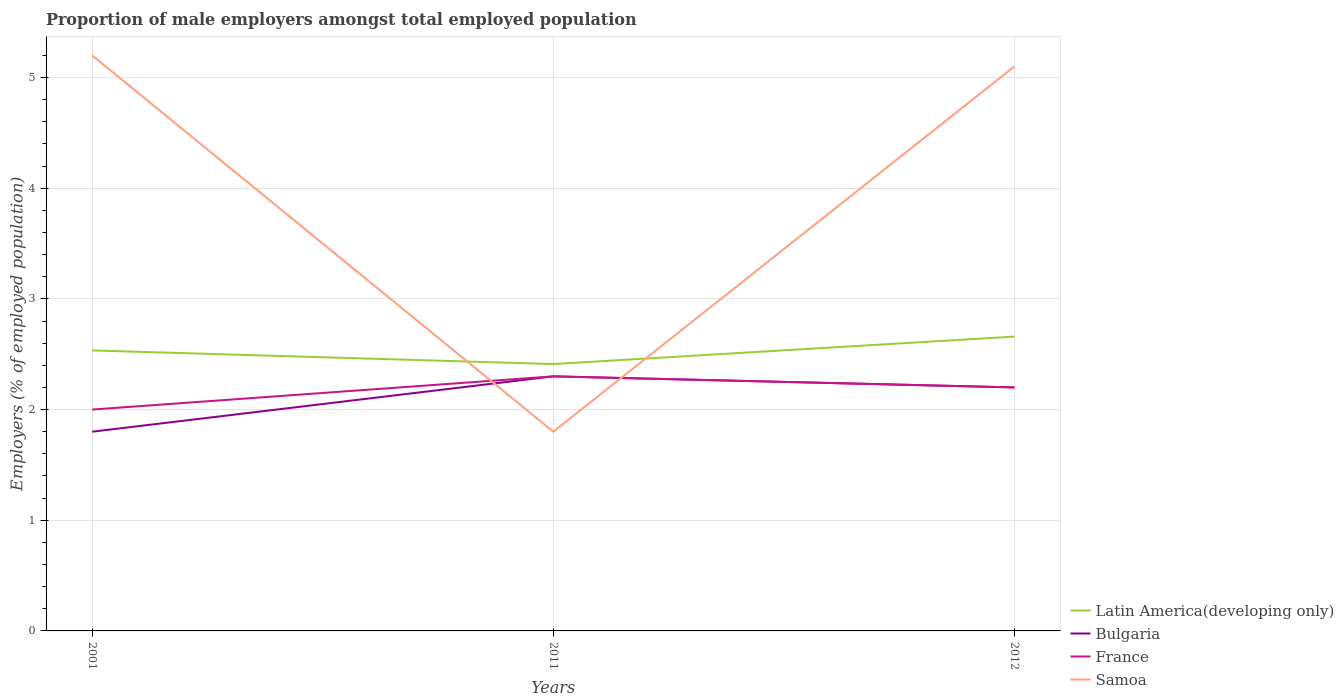Does the line corresponding to Samoa intersect with the line corresponding to Bulgaria?
Give a very brief answer. Yes. Across all years, what is the maximum proportion of male employers in Bulgaria?
Offer a very short reply. 1.8. What is the total proportion of male employers in Samoa in the graph?
Offer a very short reply. 0.1. What is the difference between the highest and the second highest proportion of male employers in France?
Your answer should be compact. 0.3. What is the difference between the highest and the lowest proportion of male employers in Samoa?
Your answer should be very brief. 2. Is the proportion of male employers in Latin America(developing only) strictly greater than the proportion of male employers in France over the years?
Your answer should be very brief. No. Does the graph contain any zero values?
Give a very brief answer. No. Does the graph contain grids?
Offer a very short reply. Yes. Where does the legend appear in the graph?
Ensure brevity in your answer.  Bottom right. What is the title of the graph?
Provide a succinct answer. Proportion of male employers amongst total employed population. What is the label or title of the Y-axis?
Offer a terse response. Employers (% of employed population). What is the Employers (% of employed population) of Latin America(developing only) in 2001?
Give a very brief answer. 2.53. What is the Employers (% of employed population) of Bulgaria in 2001?
Your answer should be compact. 1.8. What is the Employers (% of employed population) of Samoa in 2001?
Your response must be concise. 5.2. What is the Employers (% of employed population) in Latin America(developing only) in 2011?
Your answer should be very brief. 2.41. What is the Employers (% of employed population) of Bulgaria in 2011?
Offer a very short reply. 2.3. What is the Employers (% of employed population) of France in 2011?
Ensure brevity in your answer.  2.3. What is the Employers (% of employed population) in Samoa in 2011?
Provide a short and direct response. 1.8. What is the Employers (% of employed population) in Latin America(developing only) in 2012?
Ensure brevity in your answer.  2.66. What is the Employers (% of employed population) in Bulgaria in 2012?
Your answer should be very brief. 2.2. What is the Employers (% of employed population) in France in 2012?
Provide a short and direct response. 2.2. What is the Employers (% of employed population) in Samoa in 2012?
Offer a very short reply. 5.1. Across all years, what is the maximum Employers (% of employed population) of Latin America(developing only)?
Provide a short and direct response. 2.66. Across all years, what is the maximum Employers (% of employed population) in Bulgaria?
Provide a short and direct response. 2.3. Across all years, what is the maximum Employers (% of employed population) of France?
Provide a succinct answer. 2.3. Across all years, what is the maximum Employers (% of employed population) of Samoa?
Provide a short and direct response. 5.2. Across all years, what is the minimum Employers (% of employed population) of Latin America(developing only)?
Make the answer very short. 2.41. Across all years, what is the minimum Employers (% of employed population) in Bulgaria?
Provide a succinct answer. 1.8. Across all years, what is the minimum Employers (% of employed population) in Samoa?
Your response must be concise. 1.8. What is the total Employers (% of employed population) in Latin America(developing only) in the graph?
Your response must be concise. 7.6. What is the total Employers (% of employed population) of Bulgaria in the graph?
Provide a succinct answer. 6.3. What is the total Employers (% of employed population) in France in the graph?
Your response must be concise. 6.5. What is the total Employers (% of employed population) in Samoa in the graph?
Your response must be concise. 12.1. What is the difference between the Employers (% of employed population) of Latin America(developing only) in 2001 and that in 2011?
Give a very brief answer. 0.12. What is the difference between the Employers (% of employed population) of France in 2001 and that in 2011?
Offer a very short reply. -0.3. What is the difference between the Employers (% of employed population) of Latin America(developing only) in 2001 and that in 2012?
Your answer should be very brief. -0.12. What is the difference between the Employers (% of employed population) of France in 2001 and that in 2012?
Keep it short and to the point. -0.2. What is the difference between the Employers (% of employed population) of Samoa in 2001 and that in 2012?
Provide a short and direct response. 0.1. What is the difference between the Employers (% of employed population) in Latin America(developing only) in 2011 and that in 2012?
Provide a short and direct response. -0.25. What is the difference between the Employers (% of employed population) in Bulgaria in 2011 and that in 2012?
Your answer should be compact. 0.1. What is the difference between the Employers (% of employed population) in France in 2011 and that in 2012?
Provide a short and direct response. 0.1. What is the difference between the Employers (% of employed population) of Samoa in 2011 and that in 2012?
Ensure brevity in your answer.  -3.3. What is the difference between the Employers (% of employed population) in Latin America(developing only) in 2001 and the Employers (% of employed population) in Bulgaria in 2011?
Make the answer very short. 0.23. What is the difference between the Employers (% of employed population) in Latin America(developing only) in 2001 and the Employers (% of employed population) in France in 2011?
Keep it short and to the point. 0.23. What is the difference between the Employers (% of employed population) of Latin America(developing only) in 2001 and the Employers (% of employed population) of Samoa in 2011?
Your answer should be very brief. 0.73. What is the difference between the Employers (% of employed population) in Bulgaria in 2001 and the Employers (% of employed population) in Samoa in 2011?
Ensure brevity in your answer.  0. What is the difference between the Employers (% of employed population) of Latin America(developing only) in 2001 and the Employers (% of employed population) of Bulgaria in 2012?
Ensure brevity in your answer.  0.33. What is the difference between the Employers (% of employed population) of Latin America(developing only) in 2001 and the Employers (% of employed population) of France in 2012?
Provide a short and direct response. 0.33. What is the difference between the Employers (% of employed population) of Latin America(developing only) in 2001 and the Employers (% of employed population) of Samoa in 2012?
Ensure brevity in your answer.  -2.57. What is the difference between the Employers (% of employed population) in Bulgaria in 2001 and the Employers (% of employed population) in Samoa in 2012?
Make the answer very short. -3.3. What is the difference between the Employers (% of employed population) in Latin America(developing only) in 2011 and the Employers (% of employed population) in Bulgaria in 2012?
Your answer should be very brief. 0.21. What is the difference between the Employers (% of employed population) of Latin America(developing only) in 2011 and the Employers (% of employed population) of France in 2012?
Your answer should be compact. 0.21. What is the difference between the Employers (% of employed population) in Latin America(developing only) in 2011 and the Employers (% of employed population) in Samoa in 2012?
Provide a short and direct response. -2.69. What is the difference between the Employers (% of employed population) of Bulgaria in 2011 and the Employers (% of employed population) of France in 2012?
Offer a very short reply. 0.1. What is the average Employers (% of employed population) in Latin America(developing only) per year?
Your response must be concise. 2.53. What is the average Employers (% of employed population) of France per year?
Offer a very short reply. 2.17. What is the average Employers (% of employed population) in Samoa per year?
Make the answer very short. 4.03. In the year 2001, what is the difference between the Employers (% of employed population) of Latin America(developing only) and Employers (% of employed population) of Bulgaria?
Offer a very short reply. 0.73. In the year 2001, what is the difference between the Employers (% of employed population) of Latin America(developing only) and Employers (% of employed population) of France?
Your answer should be compact. 0.53. In the year 2001, what is the difference between the Employers (% of employed population) of Latin America(developing only) and Employers (% of employed population) of Samoa?
Offer a very short reply. -2.67. In the year 2001, what is the difference between the Employers (% of employed population) in Bulgaria and Employers (% of employed population) in Samoa?
Ensure brevity in your answer.  -3.4. In the year 2001, what is the difference between the Employers (% of employed population) in France and Employers (% of employed population) in Samoa?
Give a very brief answer. -3.2. In the year 2011, what is the difference between the Employers (% of employed population) in Latin America(developing only) and Employers (% of employed population) in Samoa?
Offer a terse response. 0.61. In the year 2011, what is the difference between the Employers (% of employed population) of Bulgaria and Employers (% of employed population) of France?
Your answer should be compact. 0. In the year 2011, what is the difference between the Employers (% of employed population) in France and Employers (% of employed population) in Samoa?
Keep it short and to the point. 0.5. In the year 2012, what is the difference between the Employers (% of employed population) in Latin America(developing only) and Employers (% of employed population) in Bulgaria?
Your answer should be very brief. 0.46. In the year 2012, what is the difference between the Employers (% of employed population) in Latin America(developing only) and Employers (% of employed population) in France?
Make the answer very short. 0.46. In the year 2012, what is the difference between the Employers (% of employed population) in Latin America(developing only) and Employers (% of employed population) in Samoa?
Give a very brief answer. -2.44. In the year 2012, what is the difference between the Employers (% of employed population) of Bulgaria and Employers (% of employed population) of France?
Make the answer very short. 0. In the year 2012, what is the difference between the Employers (% of employed population) of Bulgaria and Employers (% of employed population) of Samoa?
Offer a terse response. -2.9. What is the ratio of the Employers (% of employed population) in Latin America(developing only) in 2001 to that in 2011?
Your answer should be compact. 1.05. What is the ratio of the Employers (% of employed population) in Bulgaria in 2001 to that in 2011?
Keep it short and to the point. 0.78. What is the ratio of the Employers (% of employed population) in France in 2001 to that in 2011?
Your answer should be very brief. 0.87. What is the ratio of the Employers (% of employed population) in Samoa in 2001 to that in 2011?
Provide a short and direct response. 2.89. What is the ratio of the Employers (% of employed population) of Latin America(developing only) in 2001 to that in 2012?
Keep it short and to the point. 0.95. What is the ratio of the Employers (% of employed population) of Bulgaria in 2001 to that in 2012?
Your answer should be compact. 0.82. What is the ratio of the Employers (% of employed population) of France in 2001 to that in 2012?
Ensure brevity in your answer.  0.91. What is the ratio of the Employers (% of employed population) of Samoa in 2001 to that in 2012?
Offer a terse response. 1.02. What is the ratio of the Employers (% of employed population) in Latin America(developing only) in 2011 to that in 2012?
Offer a very short reply. 0.91. What is the ratio of the Employers (% of employed population) of Bulgaria in 2011 to that in 2012?
Give a very brief answer. 1.05. What is the ratio of the Employers (% of employed population) of France in 2011 to that in 2012?
Keep it short and to the point. 1.05. What is the ratio of the Employers (% of employed population) in Samoa in 2011 to that in 2012?
Your response must be concise. 0.35. What is the difference between the highest and the second highest Employers (% of employed population) in Samoa?
Make the answer very short. 0.1. What is the difference between the highest and the lowest Employers (% of employed population) of Latin America(developing only)?
Your answer should be very brief. 0.25. What is the difference between the highest and the lowest Employers (% of employed population) in France?
Make the answer very short. 0.3. 